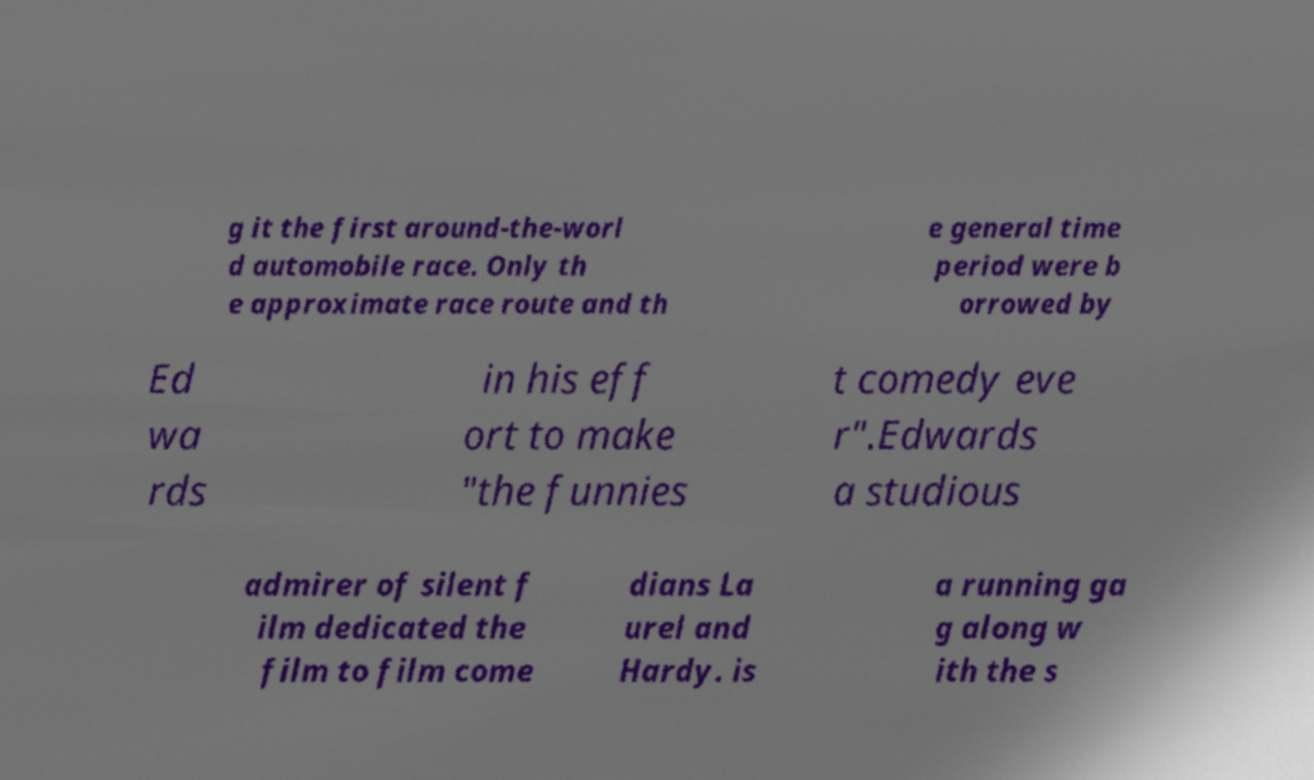Can you accurately transcribe the text from the provided image for me? g it the first around-the-worl d automobile race. Only th e approximate race route and th e general time period were b orrowed by Ed wa rds in his eff ort to make "the funnies t comedy eve r".Edwards a studious admirer of silent f ilm dedicated the film to film come dians La urel and Hardy. is a running ga g along w ith the s 